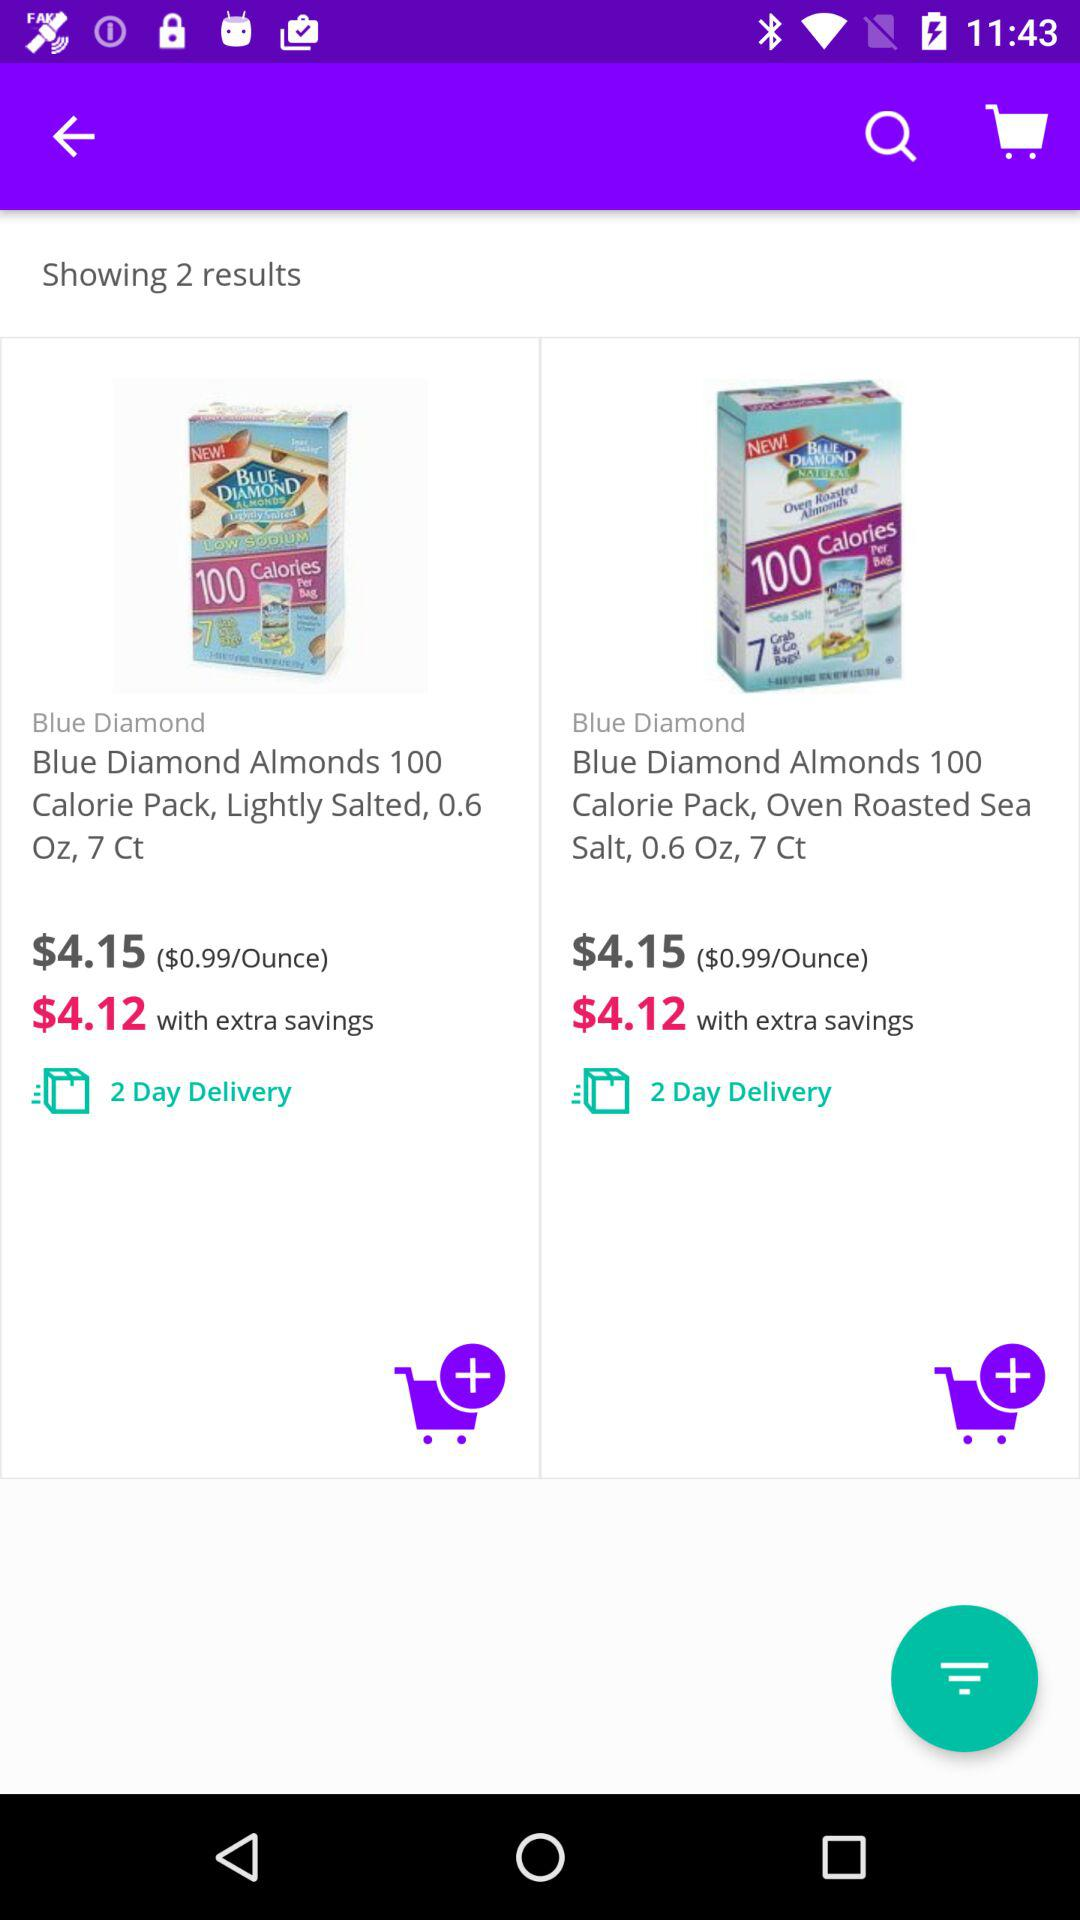How environmentally friendly is the packaging for these products? The image does not provide specific information about the environmental impact of the packaging. However, since the products are individual snack packs, there may be a concern about the use of extra materials for single servings. To get a more accurate understanding of the environmental friendliness, you might want to look into the packaging materials used by Blue Diamond and whether they have any sustainability initiatives. 